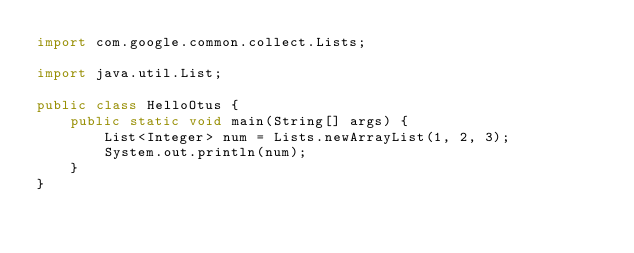Convert code to text. <code><loc_0><loc_0><loc_500><loc_500><_Java_>import com.google.common.collect.Lists;

import java.util.List;

public class HelloOtus {
    public static void main(String[] args) {
        List<Integer> num = Lists.newArrayList(1, 2, 3);
        System.out.println(num);
    }
}
</code> 